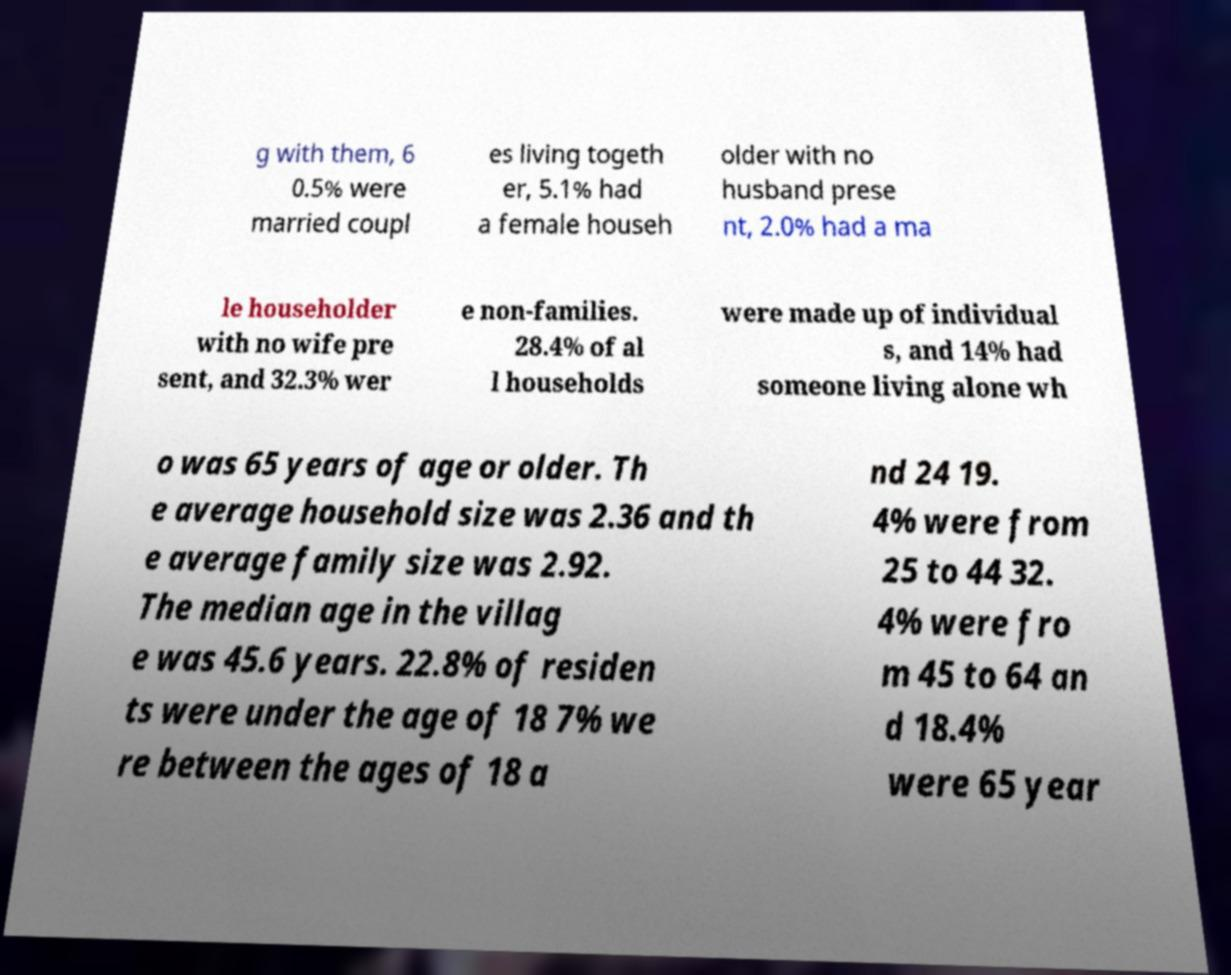Could you extract and type out the text from this image? g with them, 6 0.5% were married coupl es living togeth er, 5.1% had a female househ older with no husband prese nt, 2.0% had a ma le householder with no wife pre sent, and 32.3% wer e non-families. 28.4% of al l households were made up of individual s, and 14% had someone living alone wh o was 65 years of age or older. Th e average household size was 2.36 and th e average family size was 2.92. The median age in the villag e was 45.6 years. 22.8% of residen ts were under the age of 18 7% we re between the ages of 18 a nd 24 19. 4% were from 25 to 44 32. 4% were fro m 45 to 64 an d 18.4% were 65 year 